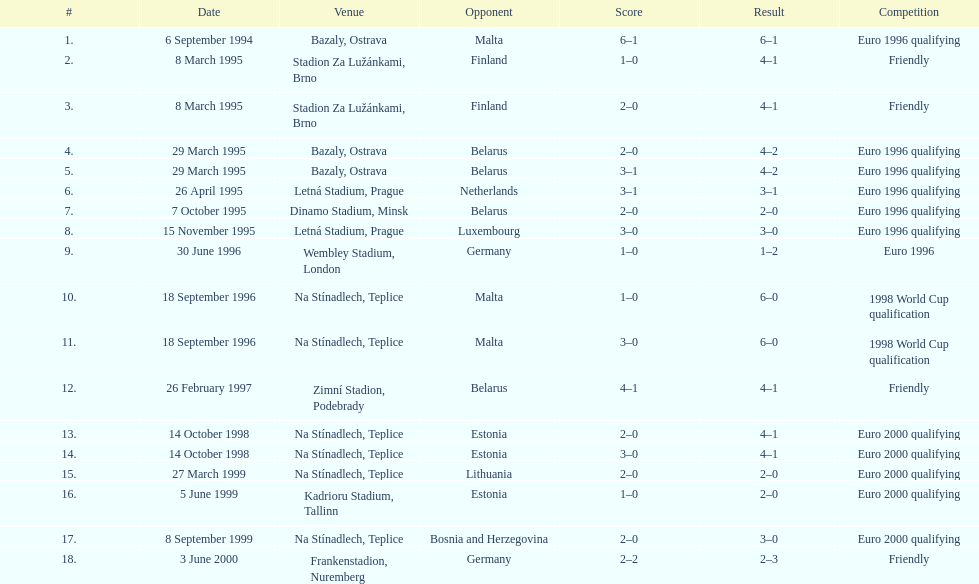Could you parse the entire table as a dict? {'header': ['#', 'Date', 'Venue', 'Opponent', 'Score', 'Result', 'Competition'], 'rows': [['1.', '6 September 1994', 'Bazaly, Ostrava', 'Malta', '6–1', '6–1', 'Euro 1996 qualifying'], ['2.', '8 March 1995', 'Stadion Za Lužánkami, Brno', 'Finland', '1–0', '4–1', 'Friendly'], ['3.', '8 March 1995', 'Stadion Za Lužánkami, Brno', 'Finland', '2–0', '4–1', 'Friendly'], ['4.', '29 March 1995', 'Bazaly, Ostrava', 'Belarus', '2–0', '4–2', 'Euro 1996 qualifying'], ['5.', '29 March 1995', 'Bazaly, Ostrava', 'Belarus', '3–1', '4–2', 'Euro 1996 qualifying'], ['6.', '26 April 1995', 'Letná Stadium, Prague', 'Netherlands', '3–1', '3–1', 'Euro 1996 qualifying'], ['7.', '7 October 1995', 'Dinamo Stadium, Minsk', 'Belarus', '2–0', '2–0', 'Euro 1996 qualifying'], ['8.', '15 November 1995', 'Letná Stadium, Prague', 'Luxembourg', '3–0', '3–0', 'Euro 1996 qualifying'], ['9.', '30 June 1996', 'Wembley Stadium, London', 'Germany', '1–0', '1–2', 'Euro 1996'], ['10.', '18 September 1996', 'Na Stínadlech, Teplice', 'Malta', '1–0', '6–0', '1998 World Cup qualification'], ['11.', '18 September 1996', 'Na Stínadlech, Teplice', 'Malta', '3–0', '6–0', '1998 World Cup qualification'], ['12.', '26 February 1997', 'Zimní Stadion, Podebrady', 'Belarus', '4–1', '4–1', 'Friendly'], ['13.', '14 October 1998', 'Na Stínadlech, Teplice', 'Estonia', '2–0', '4–1', 'Euro 2000 qualifying'], ['14.', '14 October 1998', 'Na Stínadlech, Teplice', 'Estonia', '3–0', '4–1', 'Euro 2000 qualifying'], ['15.', '27 March 1999', 'Na Stínadlech, Teplice', 'Lithuania', '2–0', '2–0', 'Euro 2000 qualifying'], ['16.', '5 June 1999', 'Kadrioru Stadium, Tallinn', 'Estonia', '1–0', '2–0', 'Euro 2000 qualifying'], ['17.', '8 September 1999', 'Na Stínadlech, Teplice', 'Bosnia and Herzegovina', '2–0', '3–0', 'Euro 2000 qualifying'], ['18.', '3 June 2000', 'Frankenstadion, Nuremberg', 'Germany', '2–2', '2–3', 'Friendly']]} How many total games took place in 1999? 3. 